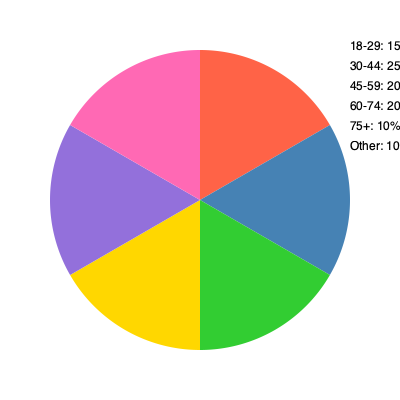The pie chart represents the age distribution of registered voters in a particular district. Which two age groups combined make up 45% of the registered voters? To solve this problem, we need to analyze the percentages for each age group and find two that add up to 45%. Let's go through the steps:

1. Identify the percentages for each age group:
   - 18-29: 15%
   - 30-44: 25%
   - 45-59: 20%
   - 60-74: 20%
   - 75+: 10%
   - Other: 10%

2. Look for combinations that add up to 45%:
   - 15% + 30% = 45% (18-29 and 30-44)
   - 25% + 20% = 45% (30-44 and 45-59)
   - 25% + 20% = 45% (30-44 and 60-74)

3. Among these combinations, only one involves two distinct age groups: 30-44 and 45-59.

Therefore, the two age groups that combined make up 45% of the registered voters are 30-44 and 45-59.
Answer: 30-44 and 45-59 